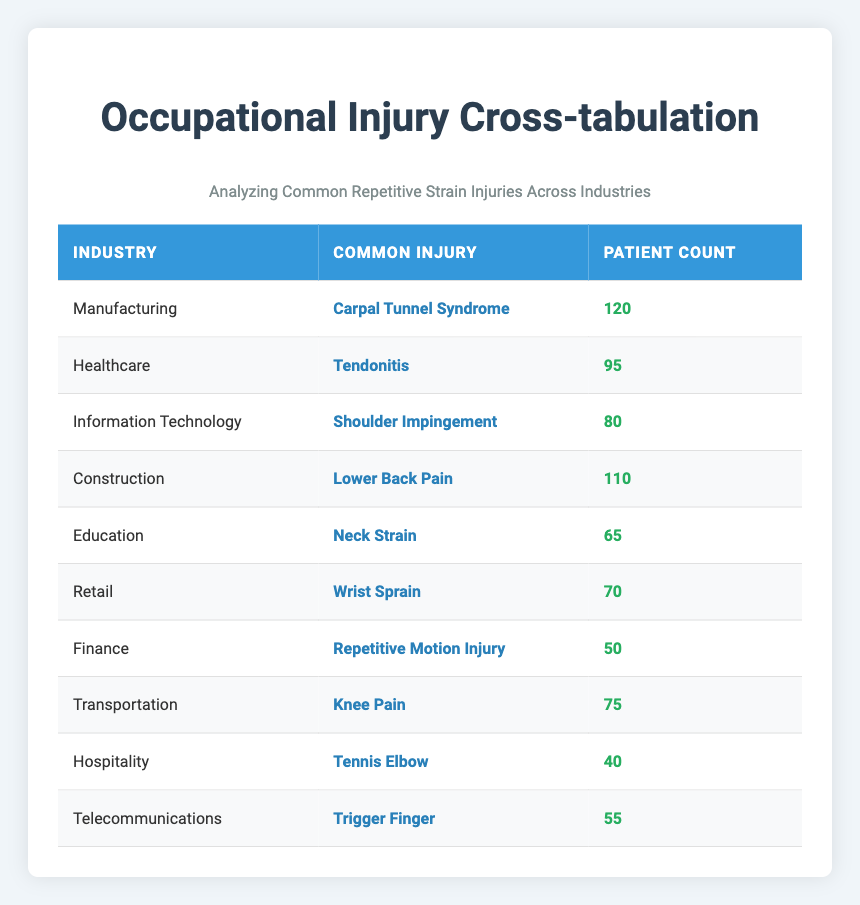What is the most common injury reported in the Manufacturing industry? The table shows that the Manufacturing industry has a count of 120 for Carpal Tunnel Syndrome, which is the highest among the listed injuries in this industry.
Answer: Carpal Tunnel Syndrome Which injury is reported by the highest number of patients in the table? To find this, I compare all the counts for each injury. The highest count is 120 for Carpal Tunnel Syndrome in the Manufacturing industry.
Answer: Carpal Tunnel Syndrome What is the total number of patients reporting injuries in the Healthcare and Transportation industries combined? The Healthcare industry reports 95 injuries and the Transportation industry reports 75 injuries. Adding these counts gives 95 + 75 = 170.
Answer: 170 Is Tennis Elbow the most frequently reported injury in the Hospitality industry? Tennis Elbow has a count of 40 in the Hospitality industry. Since there are no other injuries listed for this industry in the table, it is safe to say this is the only injury and thus the most frequently reported.
Answer: Yes Which industry has the second highest number of reported injuries, and what is that injury? The second highest count in the table is for the Construction industry with Lower Back Pain at 110, following the Manufacturing industry with Carpal Tunnel Syndrome at 120.
Answer: Construction, Lower Back Pain What is the average number of patients reporting injuries across all industries listed? I will sum the counts: (120 + 95 + 80 + 110 + 65 + 70 + 50 + 75 + 40 + 55) = 820. There are 10 entries, so the average is 820/10 = 82.
Answer: 82 Does the Finance industry have a higher number of reported injuries than the Hospitality industry? The Finance industry has 50 reported injuries while the Hospitality industry has 40. Since 50 is greater than 40, the answer is yes.
Answer: Yes What is the difference in the report count between the highest and the lowest injury counts? The highest count is 120 for Carpal Tunnel Syndrome, and the lowest is 40 for Tennis Elbow. The difference is 120 - 40 = 80.
Answer: 80 Which two industries report injuries related to the upper extremity (e.g., wrist, finger, shoulder)? The upper extremity injuries listed are Carpal Tunnel Syndrome (Manufacturing), Wrist Sprain (Retail), Shoulder Impingement (Information Technology), and Tennis Elbow (Hospitality). Thus, the industries are Manufacturing and Retail, and one could also include Information Technology and Hospitality.
Answer: Manufacturing, Retail, Information Technology, Hospitality 